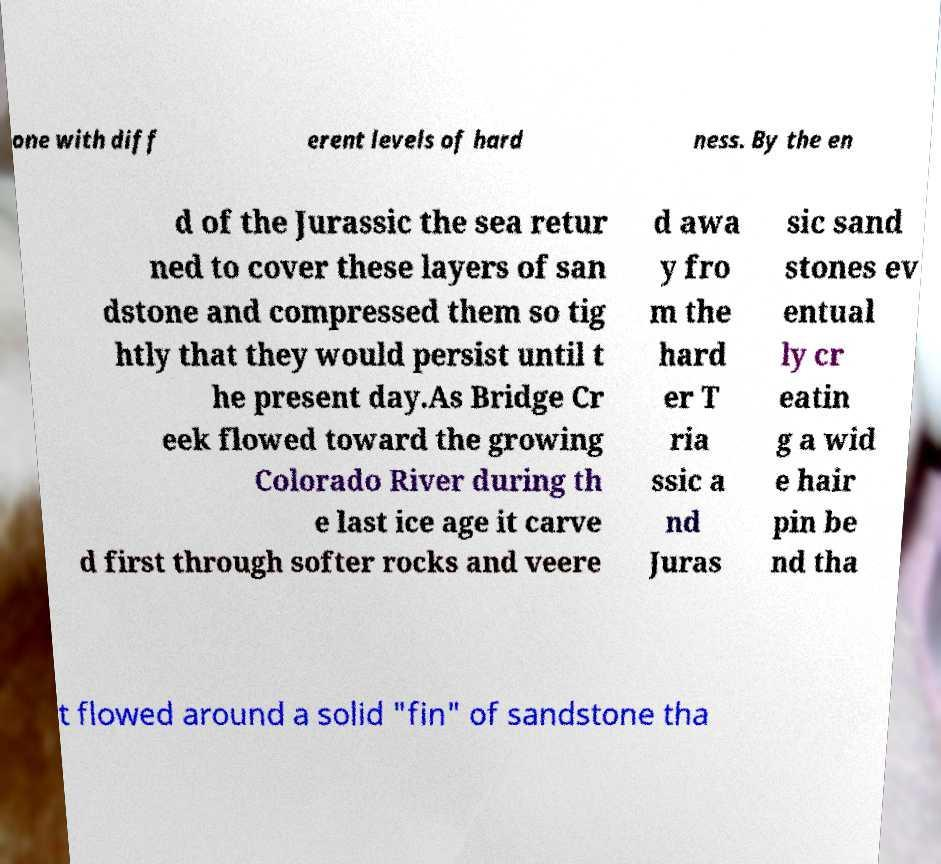Please identify and transcribe the text found in this image. one with diff erent levels of hard ness. By the en d of the Jurassic the sea retur ned to cover these layers of san dstone and compressed them so tig htly that they would persist until t he present day.As Bridge Cr eek flowed toward the growing Colorado River during th e last ice age it carve d first through softer rocks and veere d awa y fro m the hard er T ria ssic a nd Juras sic sand stones ev entual ly cr eatin g a wid e hair pin be nd tha t flowed around a solid "fin" of sandstone tha 